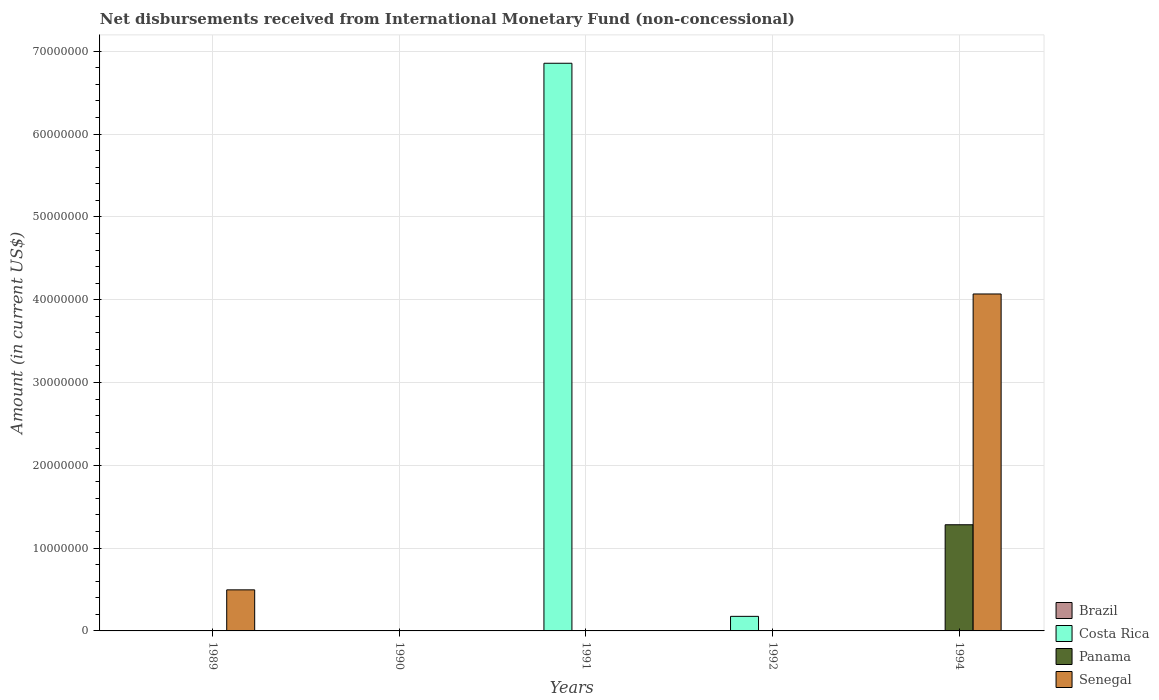What is the amount of disbursements received from International Monetary Fund in Senegal in 1990?
Ensure brevity in your answer.  0. Across all years, what is the maximum amount of disbursements received from International Monetary Fund in Senegal?
Keep it short and to the point. 4.07e+07. In which year was the amount of disbursements received from International Monetary Fund in Senegal maximum?
Provide a succinct answer. 1994. What is the total amount of disbursements received from International Monetary Fund in Costa Rica in the graph?
Give a very brief answer. 7.03e+07. What is the difference between the amount of disbursements received from International Monetary Fund in Costa Rica in 1991 and that in 1992?
Your answer should be very brief. 6.68e+07. What is the difference between the amount of disbursements received from International Monetary Fund in Panama in 1991 and the amount of disbursements received from International Monetary Fund in Senegal in 1994?
Your answer should be compact. -4.07e+07. What is the average amount of disbursements received from International Monetary Fund in Costa Rica per year?
Your answer should be very brief. 1.41e+07. What is the difference between the highest and the lowest amount of disbursements received from International Monetary Fund in Senegal?
Provide a short and direct response. 4.07e+07. In how many years, is the amount of disbursements received from International Monetary Fund in Senegal greater than the average amount of disbursements received from International Monetary Fund in Senegal taken over all years?
Provide a short and direct response. 1. Is it the case that in every year, the sum of the amount of disbursements received from International Monetary Fund in Costa Rica and amount of disbursements received from International Monetary Fund in Brazil is greater than the amount of disbursements received from International Monetary Fund in Senegal?
Make the answer very short. No. How many bars are there?
Make the answer very short. 5. How many years are there in the graph?
Make the answer very short. 5. Does the graph contain grids?
Offer a very short reply. Yes. Where does the legend appear in the graph?
Give a very brief answer. Bottom right. How many legend labels are there?
Your answer should be very brief. 4. What is the title of the graph?
Your answer should be very brief. Net disbursements received from International Monetary Fund (non-concessional). What is the label or title of the X-axis?
Your response must be concise. Years. What is the label or title of the Y-axis?
Ensure brevity in your answer.  Amount (in current US$). What is the Amount (in current US$) of Costa Rica in 1989?
Ensure brevity in your answer.  0. What is the Amount (in current US$) of Senegal in 1989?
Keep it short and to the point. 4.96e+06. What is the Amount (in current US$) of Brazil in 1990?
Offer a very short reply. 0. What is the Amount (in current US$) in Costa Rica in 1990?
Make the answer very short. 0. What is the Amount (in current US$) in Panama in 1990?
Provide a succinct answer. 0. What is the Amount (in current US$) in Senegal in 1990?
Your response must be concise. 0. What is the Amount (in current US$) in Brazil in 1991?
Offer a terse response. 0. What is the Amount (in current US$) in Costa Rica in 1991?
Make the answer very short. 6.86e+07. What is the Amount (in current US$) in Panama in 1991?
Give a very brief answer. 0. What is the Amount (in current US$) in Brazil in 1992?
Give a very brief answer. 0. What is the Amount (in current US$) in Costa Rica in 1992?
Ensure brevity in your answer.  1.76e+06. What is the Amount (in current US$) in Brazil in 1994?
Make the answer very short. 0. What is the Amount (in current US$) in Panama in 1994?
Offer a terse response. 1.28e+07. What is the Amount (in current US$) of Senegal in 1994?
Provide a short and direct response. 4.07e+07. Across all years, what is the maximum Amount (in current US$) in Costa Rica?
Provide a short and direct response. 6.86e+07. Across all years, what is the maximum Amount (in current US$) in Panama?
Give a very brief answer. 1.28e+07. Across all years, what is the maximum Amount (in current US$) of Senegal?
Your answer should be very brief. 4.07e+07. Across all years, what is the minimum Amount (in current US$) in Costa Rica?
Ensure brevity in your answer.  0. Across all years, what is the minimum Amount (in current US$) in Senegal?
Keep it short and to the point. 0. What is the total Amount (in current US$) of Brazil in the graph?
Your answer should be compact. 0. What is the total Amount (in current US$) in Costa Rica in the graph?
Offer a terse response. 7.03e+07. What is the total Amount (in current US$) of Panama in the graph?
Keep it short and to the point. 1.28e+07. What is the total Amount (in current US$) of Senegal in the graph?
Offer a very short reply. 4.57e+07. What is the difference between the Amount (in current US$) in Senegal in 1989 and that in 1994?
Give a very brief answer. -3.57e+07. What is the difference between the Amount (in current US$) in Costa Rica in 1991 and that in 1992?
Offer a very short reply. 6.68e+07. What is the difference between the Amount (in current US$) in Costa Rica in 1991 and the Amount (in current US$) in Panama in 1994?
Ensure brevity in your answer.  5.57e+07. What is the difference between the Amount (in current US$) of Costa Rica in 1991 and the Amount (in current US$) of Senegal in 1994?
Make the answer very short. 2.79e+07. What is the difference between the Amount (in current US$) of Costa Rica in 1992 and the Amount (in current US$) of Panama in 1994?
Give a very brief answer. -1.11e+07. What is the difference between the Amount (in current US$) in Costa Rica in 1992 and the Amount (in current US$) in Senegal in 1994?
Provide a short and direct response. -3.89e+07. What is the average Amount (in current US$) of Costa Rica per year?
Keep it short and to the point. 1.41e+07. What is the average Amount (in current US$) of Panama per year?
Offer a terse response. 2.56e+06. What is the average Amount (in current US$) of Senegal per year?
Ensure brevity in your answer.  9.13e+06. In the year 1994, what is the difference between the Amount (in current US$) in Panama and Amount (in current US$) in Senegal?
Provide a succinct answer. -2.79e+07. What is the ratio of the Amount (in current US$) in Senegal in 1989 to that in 1994?
Give a very brief answer. 0.12. What is the ratio of the Amount (in current US$) of Costa Rica in 1991 to that in 1992?
Ensure brevity in your answer.  38.95. What is the difference between the highest and the lowest Amount (in current US$) in Costa Rica?
Offer a very short reply. 6.86e+07. What is the difference between the highest and the lowest Amount (in current US$) in Panama?
Give a very brief answer. 1.28e+07. What is the difference between the highest and the lowest Amount (in current US$) of Senegal?
Give a very brief answer. 4.07e+07. 